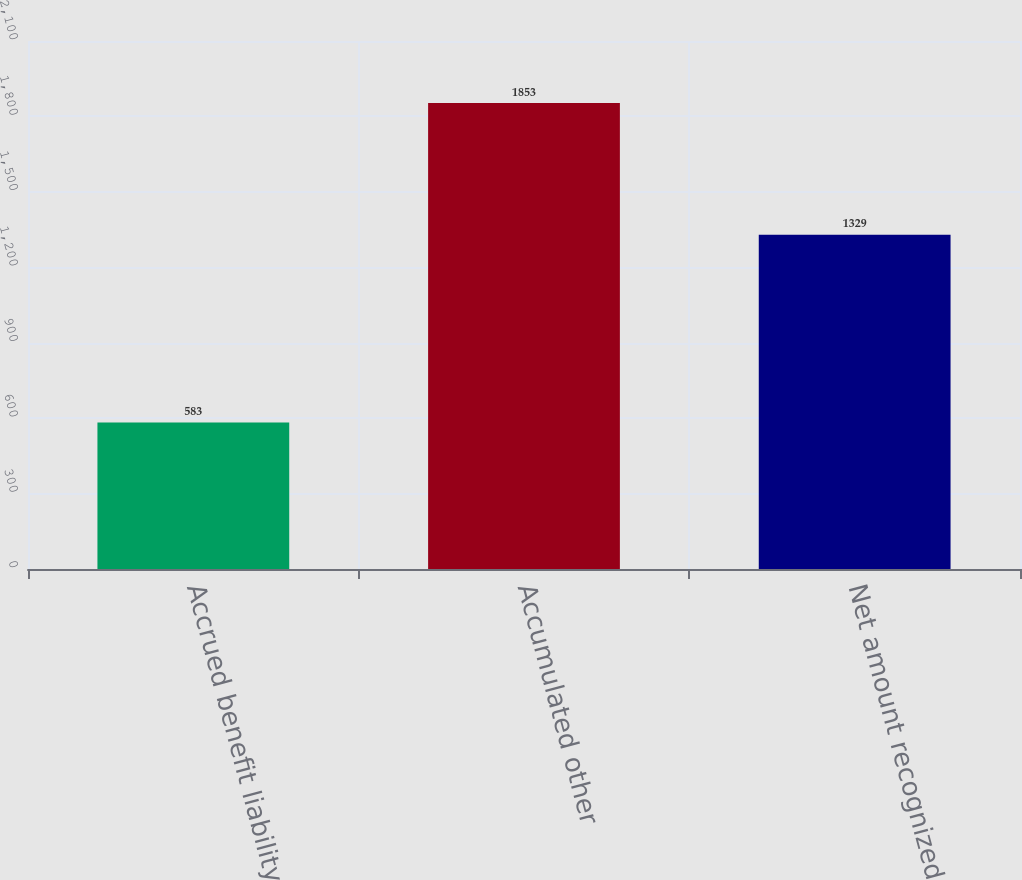Convert chart to OTSL. <chart><loc_0><loc_0><loc_500><loc_500><bar_chart><fcel>Accrued benefit liability<fcel>Accumulated other<fcel>Net amount recognized<nl><fcel>583<fcel>1853<fcel>1329<nl></chart> 